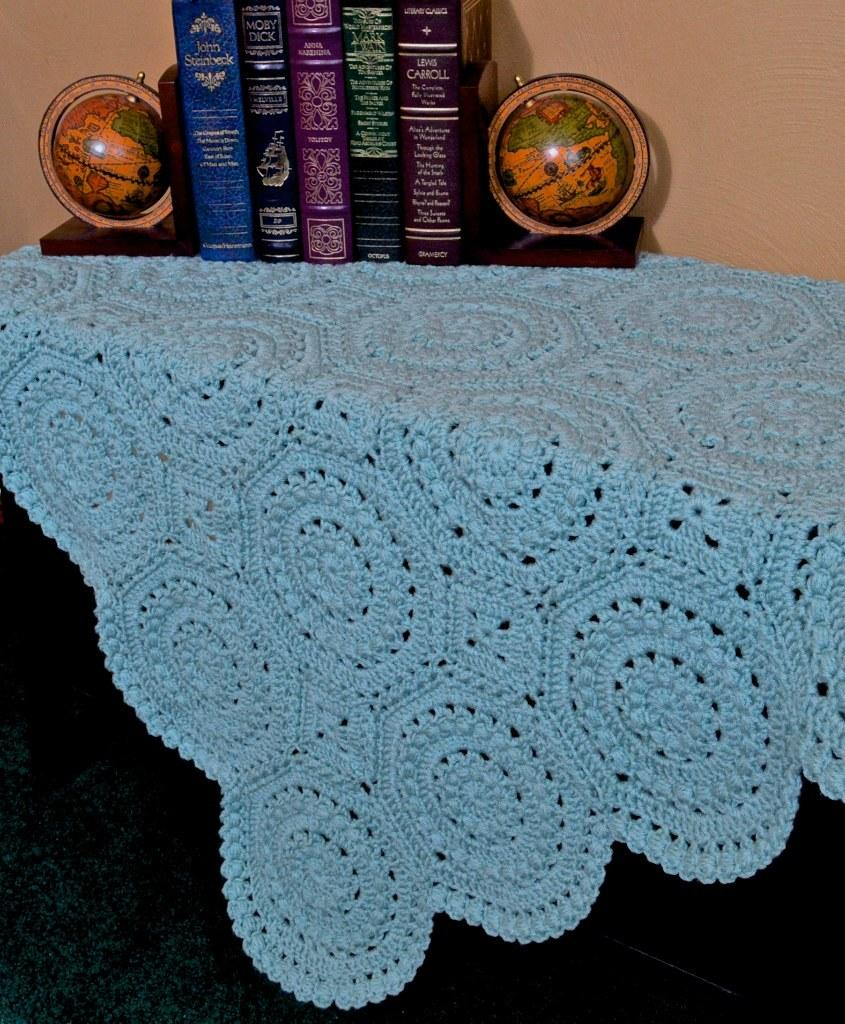Provide a one-sentence caption for the provided image. A John Steinbeck book sits next to several others on a small table. 